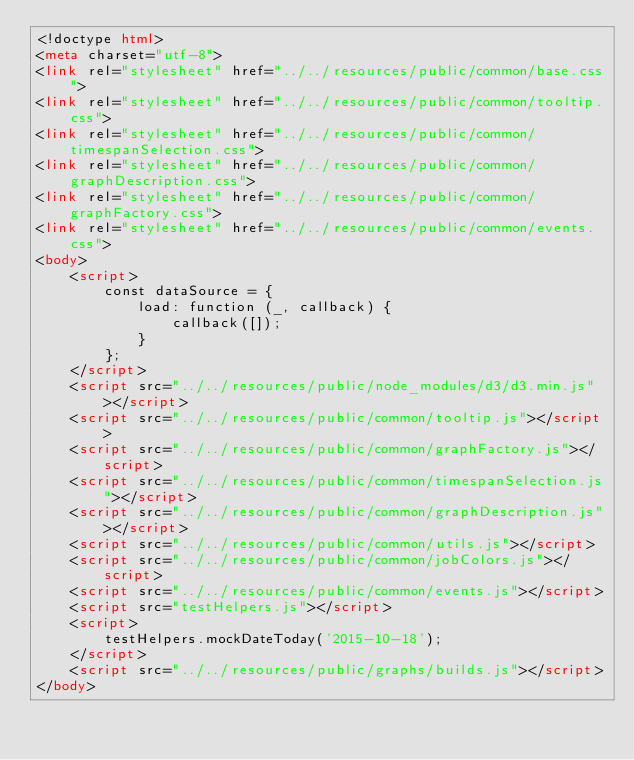<code> <loc_0><loc_0><loc_500><loc_500><_HTML_><!doctype html>
<meta charset="utf-8">
<link rel="stylesheet" href="../../resources/public/common/base.css">
<link rel="stylesheet" href="../../resources/public/common/tooltip.css">
<link rel="stylesheet" href="../../resources/public/common/timespanSelection.css">
<link rel="stylesheet" href="../../resources/public/common/graphDescription.css">
<link rel="stylesheet" href="../../resources/public/common/graphFactory.css">
<link rel="stylesheet" href="../../resources/public/common/events.css">
<body>
    <script>
        const dataSource = {
            load: function (_, callback) {
                callback([]);
            }
        };
    </script>
    <script src="../../resources/public/node_modules/d3/d3.min.js"></script>
    <script src="../../resources/public/common/tooltip.js"></script>
    <script src="../../resources/public/common/graphFactory.js"></script>
    <script src="../../resources/public/common/timespanSelection.js"></script>
    <script src="../../resources/public/common/graphDescription.js"></script>
    <script src="../../resources/public/common/utils.js"></script>
    <script src="../../resources/public/common/jobColors.js"></script>
    <script src="../../resources/public/common/events.js"></script>
    <script src="testHelpers.js"></script>
    <script>
        testHelpers.mockDateToday('2015-10-18');
    </script>
    <script src="../../resources/public/graphs/builds.js"></script>
</body>
</code> 